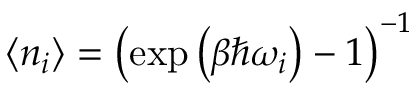Convert formula to latex. <formula><loc_0><loc_0><loc_500><loc_500>\langle n _ { i } \rangle = \left ( \exp \left ( \beta \hbar { \omega } _ { i } \right ) - 1 \right ) ^ { - 1 }</formula> 